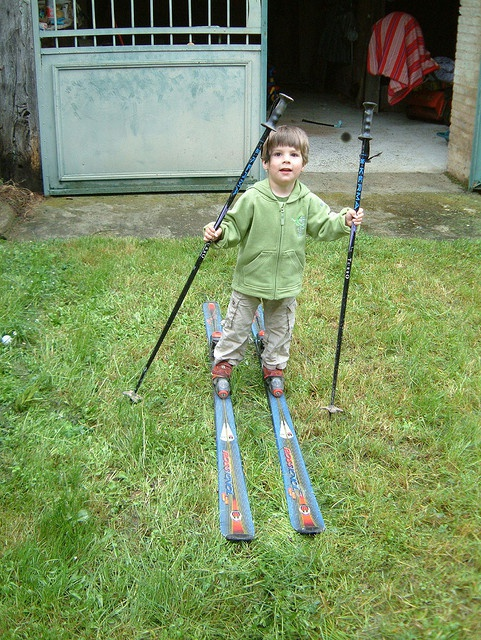Describe the objects in this image and their specific colors. I can see people in gray, darkgray, lightgreen, beige, and olive tones and skis in gray, lightblue, and darkgray tones in this image. 